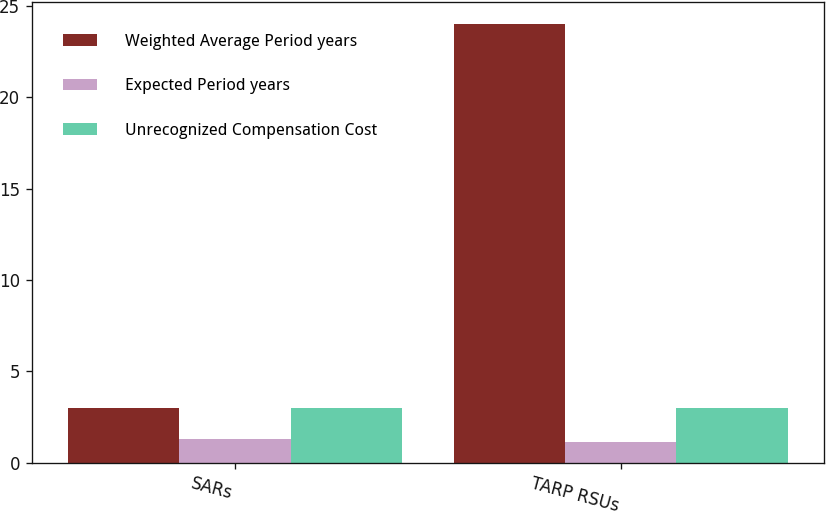Convert chart. <chart><loc_0><loc_0><loc_500><loc_500><stacked_bar_chart><ecel><fcel>SARs<fcel>TARP RSUs<nl><fcel>Weighted Average Period years<fcel>3<fcel>24<nl><fcel>Expected Period years<fcel>1.3<fcel>1.15<nl><fcel>Unrecognized Compensation Cost<fcel>3<fcel>3<nl></chart> 